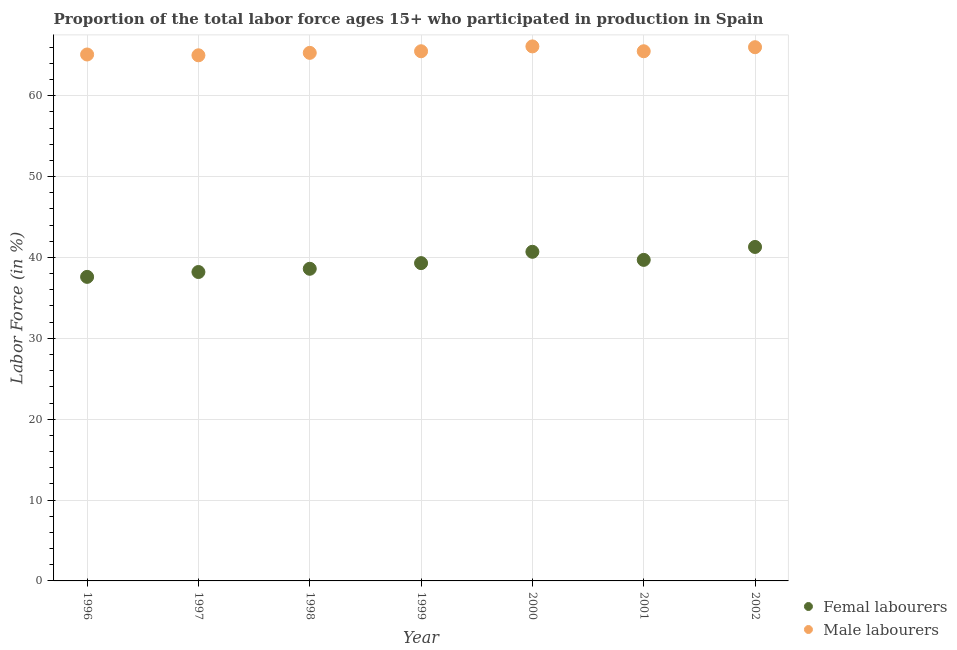What is the percentage of male labour force in 1999?
Your answer should be compact. 65.5. Across all years, what is the maximum percentage of female labor force?
Keep it short and to the point. 41.3. In which year was the percentage of female labor force minimum?
Provide a succinct answer. 1996. What is the total percentage of male labour force in the graph?
Provide a succinct answer. 458.5. What is the difference between the percentage of male labour force in 1999 and that in 2000?
Give a very brief answer. -0.6. What is the difference between the percentage of female labor force in 1999 and the percentage of male labour force in 1996?
Keep it short and to the point. -25.8. What is the average percentage of male labour force per year?
Provide a short and direct response. 65.5. In the year 1997, what is the difference between the percentage of female labor force and percentage of male labour force?
Offer a very short reply. -26.8. What is the ratio of the percentage of female labor force in 1997 to that in 1999?
Make the answer very short. 0.97. What is the difference between the highest and the second highest percentage of female labor force?
Keep it short and to the point. 0.6. What is the difference between the highest and the lowest percentage of male labour force?
Make the answer very short. 1.1. Does the percentage of female labor force monotonically increase over the years?
Give a very brief answer. No. Is the percentage of male labour force strictly greater than the percentage of female labor force over the years?
Provide a short and direct response. Yes. Is the percentage of female labor force strictly less than the percentage of male labour force over the years?
Keep it short and to the point. Yes. How many years are there in the graph?
Provide a short and direct response. 7. What is the difference between two consecutive major ticks on the Y-axis?
Make the answer very short. 10. Does the graph contain grids?
Make the answer very short. Yes. What is the title of the graph?
Offer a very short reply. Proportion of the total labor force ages 15+ who participated in production in Spain. Does "Broad money growth" appear as one of the legend labels in the graph?
Provide a succinct answer. No. What is the label or title of the Y-axis?
Ensure brevity in your answer.  Labor Force (in %). What is the Labor Force (in %) in Femal labourers in 1996?
Offer a terse response. 37.6. What is the Labor Force (in %) of Male labourers in 1996?
Make the answer very short. 65.1. What is the Labor Force (in %) of Femal labourers in 1997?
Keep it short and to the point. 38.2. What is the Labor Force (in %) of Femal labourers in 1998?
Provide a short and direct response. 38.6. What is the Labor Force (in %) of Male labourers in 1998?
Provide a short and direct response. 65.3. What is the Labor Force (in %) of Femal labourers in 1999?
Offer a very short reply. 39.3. What is the Labor Force (in %) of Male labourers in 1999?
Ensure brevity in your answer.  65.5. What is the Labor Force (in %) of Femal labourers in 2000?
Keep it short and to the point. 40.7. What is the Labor Force (in %) in Male labourers in 2000?
Make the answer very short. 66.1. What is the Labor Force (in %) in Femal labourers in 2001?
Offer a terse response. 39.7. What is the Labor Force (in %) in Male labourers in 2001?
Make the answer very short. 65.5. What is the Labor Force (in %) of Femal labourers in 2002?
Provide a short and direct response. 41.3. What is the Labor Force (in %) of Male labourers in 2002?
Your response must be concise. 66. Across all years, what is the maximum Labor Force (in %) of Femal labourers?
Offer a very short reply. 41.3. Across all years, what is the maximum Labor Force (in %) in Male labourers?
Your response must be concise. 66.1. Across all years, what is the minimum Labor Force (in %) in Femal labourers?
Give a very brief answer. 37.6. What is the total Labor Force (in %) in Femal labourers in the graph?
Your response must be concise. 275.4. What is the total Labor Force (in %) of Male labourers in the graph?
Keep it short and to the point. 458.5. What is the difference between the Labor Force (in %) of Femal labourers in 1996 and that in 1997?
Provide a succinct answer. -0.6. What is the difference between the Labor Force (in %) of Male labourers in 1996 and that in 1997?
Your answer should be very brief. 0.1. What is the difference between the Labor Force (in %) in Femal labourers in 1996 and that in 1999?
Provide a short and direct response. -1.7. What is the difference between the Labor Force (in %) of Male labourers in 1996 and that in 1999?
Make the answer very short. -0.4. What is the difference between the Labor Force (in %) in Femal labourers in 1996 and that in 2000?
Provide a short and direct response. -3.1. What is the difference between the Labor Force (in %) of Femal labourers in 1996 and that in 2001?
Your answer should be compact. -2.1. What is the difference between the Labor Force (in %) of Femal labourers in 1996 and that in 2002?
Provide a succinct answer. -3.7. What is the difference between the Labor Force (in %) of Femal labourers in 1997 and that in 1998?
Provide a succinct answer. -0.4. What is the difference between the Labor Force (in %) in Male labourers in 1997 and that in 1998?
Offer a very short reply. -0.3. What is the difference between the Labor Force (in %) of Male labourers in 1997 and that in 2000?
Make the answer very short. -1.1. What is the difference between the Labor Force (in %) of Femal labourers in 1997 and that in 2001?
Provide a short and direct response. -1.5. What is the difference between the Labor Force (in %) of Male labourers in 1997 and that in 2002?
Provide a succinct answer. -1. What is the difference between the Labor Force (in %) in Femal labourers in 1998 and that in 1999?
Provide a succinct answer. -0.7. What is the difference between the Labor Force (in %) of Male labourers in 1998 and that in 1999?
Offer a very short reply. -0.2. What is the difference between the Labor Force (in %) in Male labourers in 1998 and that in 2002?
Give a very brief answer. -0.7. What is the difference between the Labor Force (in %) in Male labourers in 1999 and that in 2000?
Make the answer very short. -0.6. What is the difference between the Labor Force (in %) in Femal labourers in 1999 and that in 2001?
Ensure brevity in your answer.  -0.4. What is the difference between the Labor Force (in %) in Male labourers in 1999 and that in 2001?
Provide a short and direct response. 0. What is the difference between the Labor Force (in %) in Femal labourers in 1999 and that in 2002?
Ensure brevity in your answer.  -2. What is the difference between the Labor Force (in %) of Male labourers in 1999 and that in 2002?
Your answer should be very brief. -0.5. What is the difference between the Labor Force (in %) in Femal labourers in 2000 and that in 2001?
Ensure brevity in your answer.  1. What is the difference between the Labor Force (in %) in Male labourers in 2000 and that in 2002?
Your answer should be very brief. 0.1. What is the difference between the Labor Force (in %) of Femal labourers in 2001 and that in 2002?
Ensure brevity in your answer.  -1.6. What is the difference between the Labor Force (in %) in Male labourers in 2001 and that in 2002?
Your response must be concise. -0.5. What is the difference between the Labor Force (in %) in Femal labourers in 1996 and the Labor Force (in %) in Male labourers in 1997?
Your answer should be very brief. -27.4. What is the difference between the Labor Force (in %) in Femal labourers in 1996 and the Labor Force (in %) in Male labourers in 1998?
Provide a short and direct response. -27.7. What is the difference between the Labor Force (in %) in Femal labourers in 1996 and the Labor Force (in %) in Male labourers in 1999?
Offer a terse response. -27.9. What is the difference between the Labor Force (in %) of Femal labourers in 1996 and the Labor Force (in %) of Male labourers in 2000?
Keep it short and to the point. -28.5. What is the difference between the Labor Force (in %) of Femal labourers in 1996 and the Labor Force (in %) of Male labourers in 2001?
Provide a succinct answer. -27.9. What is the difference between the Labor Force (in %) of Femal labourers in 1996 and the Labor Force (in %) of Male labourers in 2002?
Provide a succinct answer. -28.4. What is the difference between the Labor Force (in %) of Femal labourers in 1997 and the Labor Force (in %) of Male labourers in 1998?
Offer a terse response. -27.1. What is the difference between the Labor Force (in %) in Femal labourers in 1997 and the Labor Force (in %) in Male labourers in 1999?
Offer a terse response. -27.3. What is the difference between the Labor Force (in %) of Femal labourers in 1997 and the Labor Force (in %) of Male labourers in 2000?
Keep it short and to the point. -27.9. What is the difference between the Labor Force (in %) of Femal labourers in 1997 and the Labor Force (in %) of Male labourers in 2001?
Ensure brevity in your answer.  -27.3. What is the difference between the Labor Force (in %) in Femal labourers in 1997 and the Labor Force (in %) in Male labourers in 2002?
Your answer should be compact. -27.8. What is the difference between the Labor Force (in %) in Femal labourers in 1998 and the Labor Force (in %) in Male labourers in 1999?
Provide a succinct answer. -26.9. What is the difference between the Labor Force (in %) in Femal labourers in 1998 and the Labor Force (in %) in Male labourers in 2000?
Give a very brief answer. -27.5. What is the difference between the Labor Force (in %) in Femal labourers in 1998 and the Labor Force (in %) in Male labourers in 2001?
Provide a short and direct response. -26.9. What is the difference between the Labor Force (in %) of Femal labourers in 1998 and the Labor Force (in %) of Male labourers in 2002?
Give a very brief answer. -27.4. What is the difference between the Labor Force (in %) in Femal labourers in 1999 and the Labor Force (in %) in Male labourers in 2000?
Offer a very short reply. -26.8. What is the difference between the Labor Force (in %) of Femal labourers in 1999 and the Labor Force (in %) of Male labourers in 2001?
Give a very brief answer. -26.2. What is the difference between the Labor Force (in %) in Femal labourers in 1999 and the Labor Force (in %) in Male labourers in 2002?
Your answer should be very brief. -26.7. What is the difference between the Labor Force (in %) of Femal labourers in 2000 and the Labor Force (in %) of Male labourers in 2001?
Your response must be concise. -24.8. What is the difference between the Labor Force (in %) of Femal labourers in 2000 and the Labor Force (in %) of Male labourers in 2002?
Your response must be concise. -25.3. What is the difference between the Labor Force (in %) of Femal labourers in 2001 and the Labor Force (in %) of Male labourers in 2002?
Your answer should be compact. -26.3. What is the average Labor Force (in %) in Femal labourers per year?
Your answer should be compact. 39.34. What is the average Labor Force (in %) in Male labourers per year?
Ensure brevity in your answer.  65.5. In the year 1996, what is the difference between the Labor Force (in %) in Femal labourers and Labor Force (in %) in Male labourers?
Your answer should be very brief. -27.5. In the year 1997, what is the difference between the Labor Force (in %) of Femal labourers and Labor Force (in %) of Male labourers?
Your answer should be compact. -26.8. In the year 1998, what is the difference between the Labor Force (in %) of Femal labourers and Labor Force (in %) of Male labourers?
Ensure brevity in your answer.  -26.7. In the year 1999, what is the difference between the Labor Force (in %) of Femal labourers and Labor Force (in %) of Male labourers?
Your answer should be compact. -26.2. In the year 2000, what is the difference between the Labor Force (in %) of Femal labourers and Labor Force (in %) of Male labourers?
Your answer should be compact. -25.4. In the year 2001, what is the difference between the Labor Force (in %) of Femal labourers and Labor Force (in %) of Male labourers?
Offer a very short reply. -25.8. In the year 2002, what is the difference between the Labor Force (in %) of Femal labourers and Labor Force (in %) of Male labourers?
Ensure brevity in your answer.  -24.7. What is the ratio of the Labor Force (in %) in Femal labourers in 1996 to that in 1997?
Your answer should be very brief. 0.98. What is the ratio of the Labor Force (in %) in Male labourers in 1996 to that in 1997?
Your answer should be compact. 1. What is the ratio of the Labor Force (in %) in Femal labourers in 1996 to that in 1998?
Give a very brief answer. 0.97. What is the ratio of the Labor Force (in %) in Femal labourers in 1996 to that in 1999?
Your answer should be compact. 0.96. What is the ratio of the Labor Force (in %) in Femal labourers in 1996 to that in 2000?
Your response must be concise. 0.92. What is the ratio of the Labor Force (in %) in Male labourers in 1996 to that in 2000?
Ensure brevity in your answer.  0.98. What is the ratio of the Labor Force (in %) of Femal labourers in 1996 to that in 2001?
Make the answer very short. 0.95. What is the ratio of the Labor Force (in %) of Femal labourers in 1996 to that in 2002?
Give a very brief answer. 0.91. What is the ratio of the Labor Force (in %) of Male labourers in 1996 to that in 2002?
Provide a short and direct response. 0.99. What is the ratio of the Labor Force (in %) of Male labourers in 1997 to that in 1999?
Provide a short and direct response. 0.99. What is the ratio of the Labor Force (in %) of Femal labourers in 1997 to that in 2000?
Ensure brevity in your answer.  0.94. What is the ratio of the Labor Force (in %) in Male labourers in 1997 to that in 2000?
Offer a very short reply. 0.98. What is the ratio of the Labor Force (in %) in Femal labourers in 1997 to that in 2001?
Provide a succinct answer. 0.96. What is the ratio of the Labor Force (in %) in Male labourers in 1997 to that in 2001?
Keep it short and to the point. 0.99. What is the ratio of the Labor Force (in %) of Femal labourers in 1997 to that in 2002?
Offer a terse response. 0.92. What is the ratio of the Labor Force (in %) in Femal labourers in 1998 to that in 1999?
Offer a very short reply. 0.98. What is the ratio of the Labor Force (in %) of Male labourers in 1998 to that in 1999?
Ensure brevity in your answer.  1. What is the ratio of the Labor Force (in %) of Femal labourers in 1998 to that in 2000?
Keep it short and to the point. 0.95. What is the ratio of the Labor Force (in %) of Male labourers in 1998 to that in 2000?
Provide a succinct answer. 0.99. What is the ratio of the Labor Force (in %) in Femal labourers in 1998 to that in 2001?
Keep it short and to the point. 0.97. What is the ratio of the Labor Force (in %) in Femal labourers in 1998 to that in 2002?
Give a very brief answer. 0.93. What is the ratio of the Labor Force (in %) in Femal labourers in 1999 to that in 2000?
Provide a succinct answer. 0.97. What is the ratio of the Labor Force (in %) in Male labourers in 1999 to that in 2000?
Offer a terse response. 0.99. What is the ratio of the Labor Force (in %) of Femal labourers in 1999 to that in 2001?
Give a very brief answer. 0.99. What is the ratio of the Labor Force (in %) in Femal labourers in 1999 to that in 2002?
Ensure brevity in your answer.  0.95. What is the ratio of the Labor Force (in %) of Male labourers in 1999 to that in 2002?
Ensure brevity in your answer.  0.99. What is the ratio of the Labor Force (in %) in Femal labourers in 2000 to that in 2001?
Your response must be concise. 1.03. What is the ratio of the Labor Force (in %) in Male labourers in 2000 to that in 2001?
Your answer should be compact. 1.01. What is the ratio of the Labor Force (in %) in Femal labourers in 2000 to that in 2002?
Make the answer very short. 0.99. What is the ratio of the Labor Force (in %) of Femal labourers in 2001 to that in 2002?
Your response must be concise. 0.96. What is the ratio of the Labor Force (in %) in Male labourers in 2001 to that in 2002?
Your response must be concise. 0.99. What is the difference between the highest and the lowest Labor Force (in %) in Male labourers?
Provide a short and direct response. 1.1. 